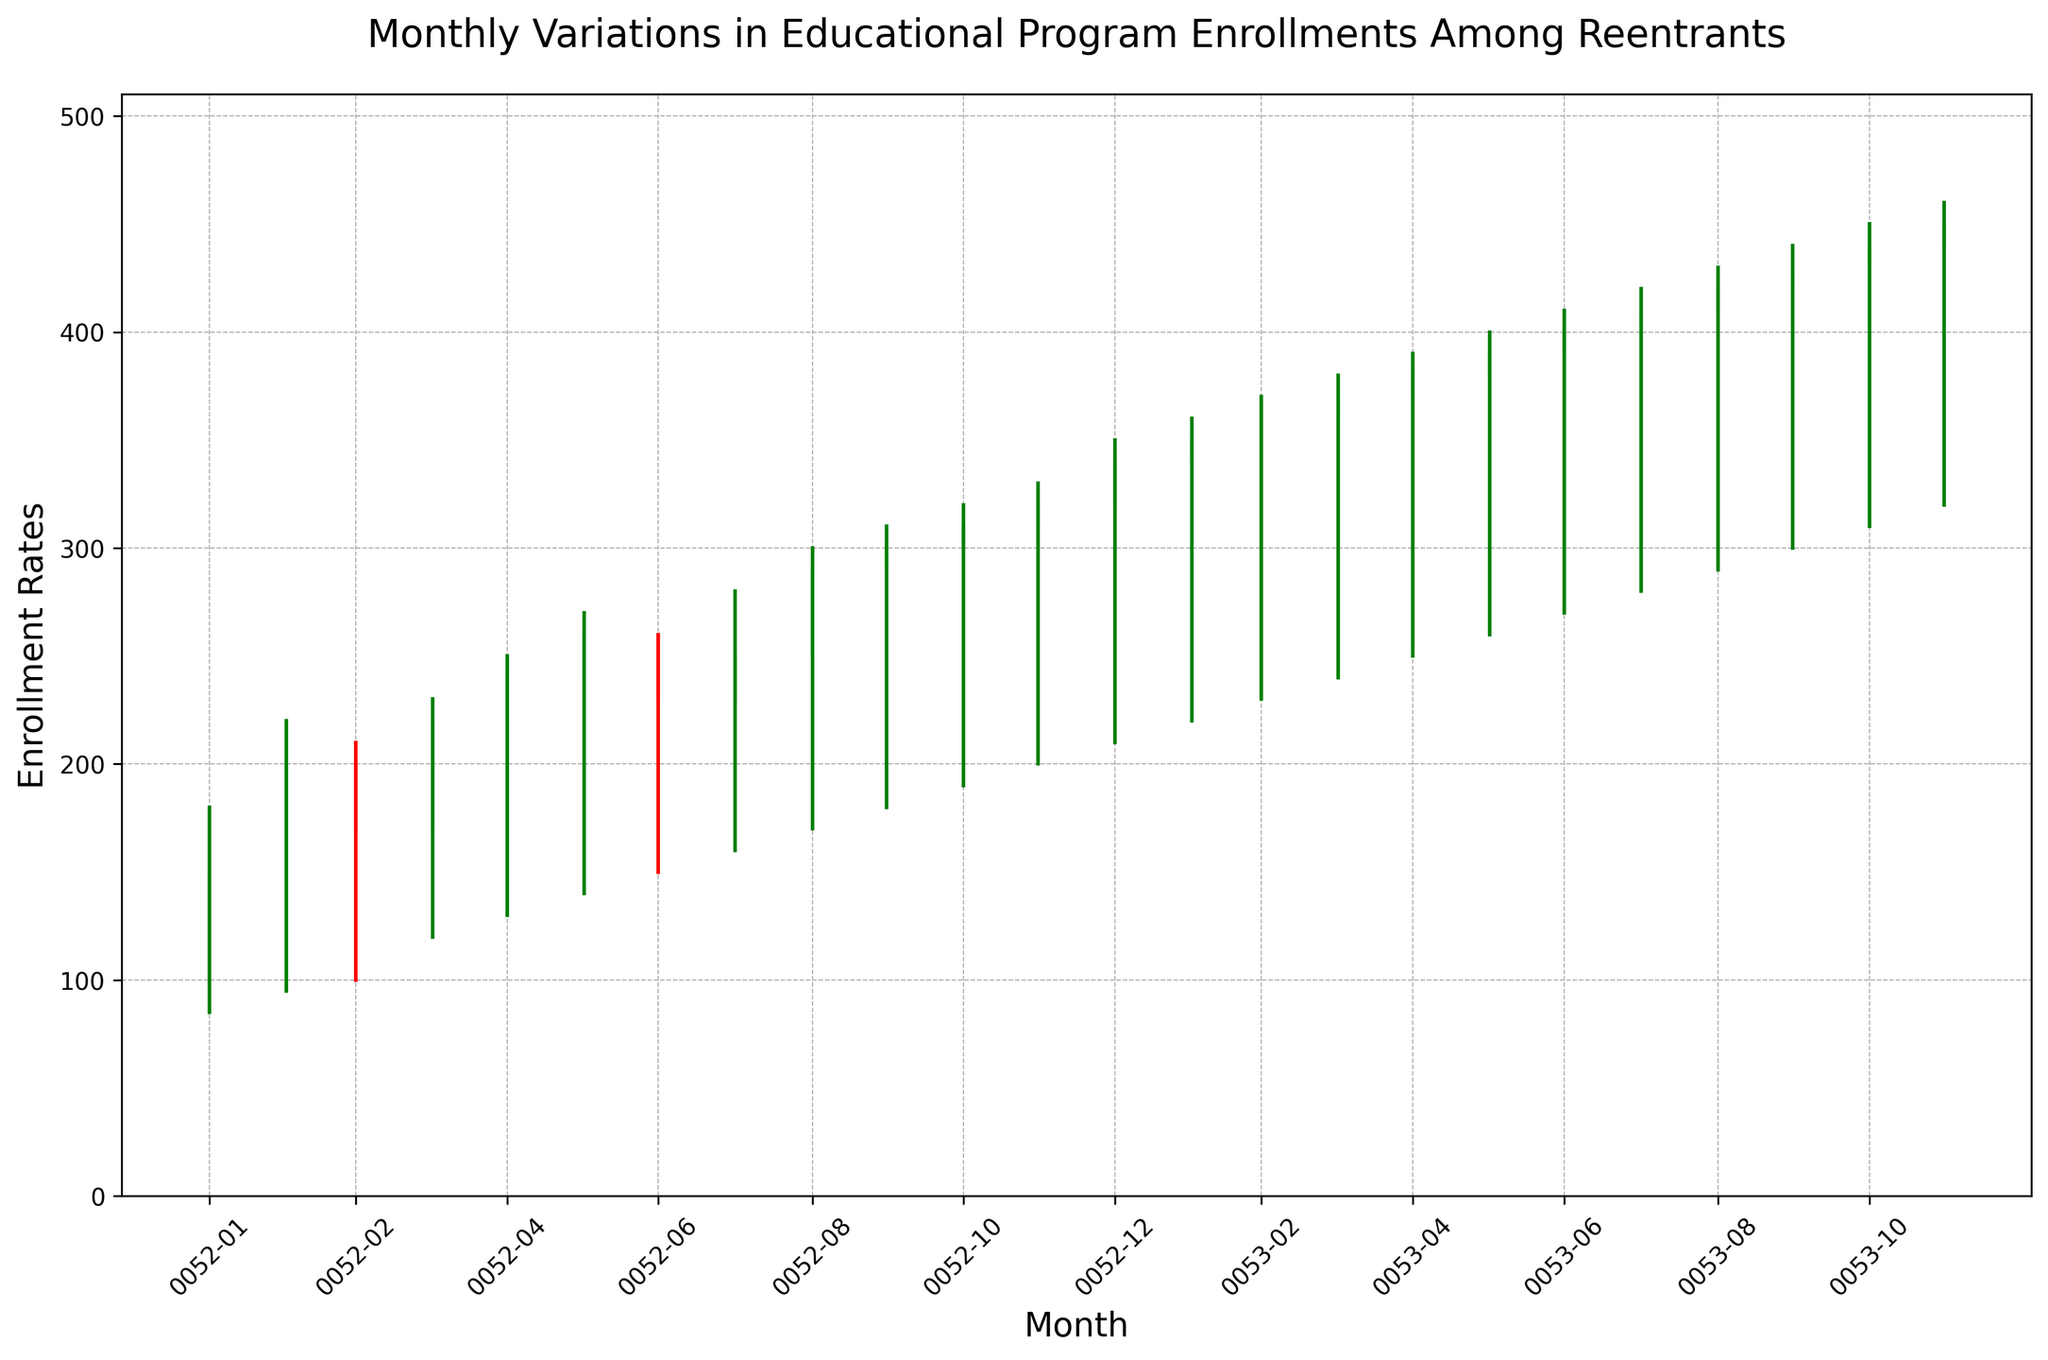How did the enrollment rates change from January 2021 to December 2022? By observing the chart, the general trend can be seen as an increase from January 2021 to December 2022. January 2021 started at an opening rate of 100 and a closing rate of 150. December 2022 ended at an opening rate of 440 and a closing rate of 450.
Answer: Increased Which month experienced the highest enrollment rate spike? The spike can be identified by the longest candlestick body, particularly the green ones indicating a significant closing rate above the opening rate. The month with the highest spike is identified by the highest green candlestick body. Observing, it's January 2022 (opening at 320 and closing at 340).
Answer: January 2022 In which month was the lowest enrollment rate recorded? The lowest enrollment rate can be observed by identifying the lowest "Low" value in the figure, which gives the minimum recorded value. By checking visually, January 2021 had the lowest enrollment, with the lowest value of 85.
Answer: January 2021 Compare the enrollment rates of February 2021 and February 2022. Which month had a higher closing rate, and by how much? February 2021 had a closing rate of 200 and February 2022 had a closing rate of 350. Subtracting 200 from 350 gives the difference in closing rates.
Answer: February 2022, by 150 What was the maximum high value recorded in the data? The maximum high value is observed by identifying the highest point of the candlesticks over the entire range. December 2022 had the highest value at 460.
Answer: 460 During which month did the enrollment open at the highest rate? The opening rates across the months can be compared to find that December 2022 had the highest opening rate of 440.
Answer: December 2022 In which month(s) did the closing rate equal the opening rate? The closing rate equals the opening rate in months where the candlestick body is not visible (i.e., zero height). No months have such a characteristic; hence no month had closing rates equaling the opening rates.
Answer: None What is the average closing rate for the year 2021? Add all the closing rates from January 2021 to December 2021 and divide by the number of months (12): (150 + 200 + 170 + 220 + 240 + 260 + 230 + 250 + 290 + 300 + 310 + 320) / 12 = 274.1667
Answer: 274.17 Which month showed a decrease in enrollment from its opening to its closing rate? Decreases in enrollment can be identified by red candlesticks. The red candlesticks for March 2021 and July 2021 show a decrease from their opening to closing rates, March 2021 decreased from 200 to 170, and July 2021 from 260 to 230.
Answer: March 2021, July 2021 What's the range of enrollment rates for September 2021? The range of enrollment rates for a month is the difference between the high and low values. For September 2021, the high was 300 and the low was 170. Range = 300 - 170 = 130.
Answer: 130 